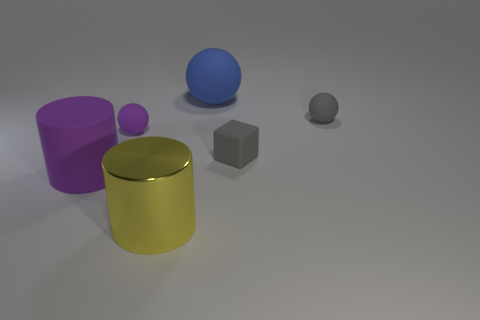Add 2 large metal spheres. How many objects exist? 8 Subtract all blocks. How many objects are left? 5 Subtract 0 red balls. How many objects are left? 6 Subtract all cubes. Subtract all large brown matte spheres. How many objects are left? 5 Add 4 purple matte things. How many purple matte things are left? 6 Add 5 shiny things. How many shiny things exist? 6 